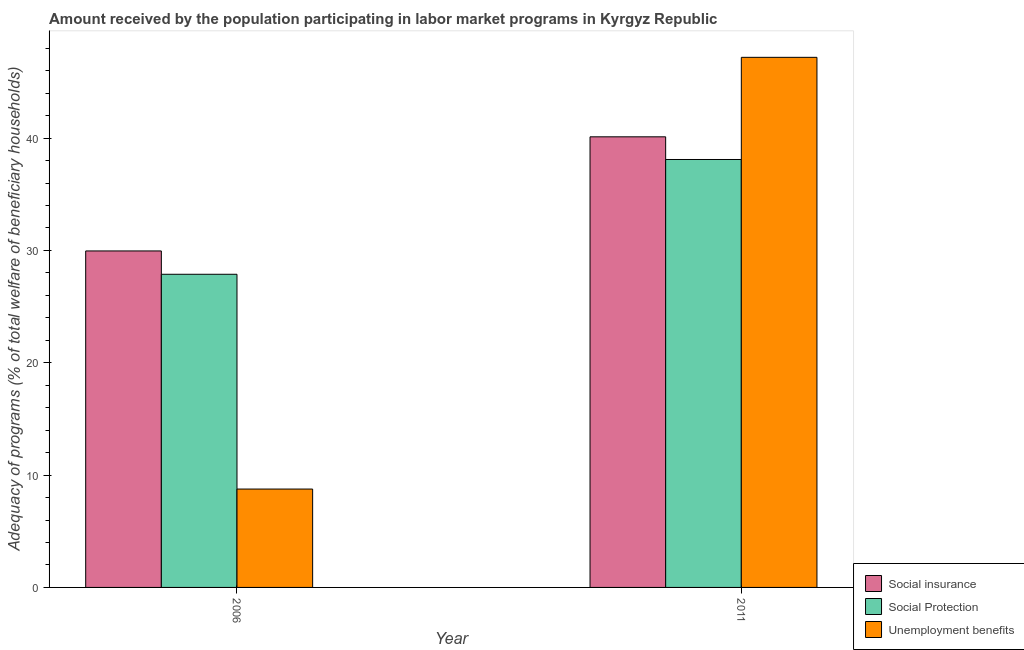Are the number of bars per tick equal to the number of legend labels?
Keep it short and to the point. Yes. Are the number of bars on each tick of the X-axis equal?
Offer a terse response. Yes. How many bars are there on the 1st tick from the left?
Make the answer very short. 3. What is the amount received by the population participating in unemployment benefits programs in 2006?
Make the answer very short. 8.76. Across all years, what is the maximum amount received by the population participating in social protection programs?
Offer a terse response. 38.1. Across all years, what is the minimum amount received by the population participating in unemployment benefits programs?
Make the answer very short. 8.76. In which year was the amount received by the population participating in social protection programs minimum?
Ensure brevity in your answer.  2006. What is the total amount received by the population participating in unemployment benefits programs in the graph?
Offer a terse response. 55.95. What is the difference between the amount received by the population participating in social protection programs in 2006 and that in 2011?
Offer a terse response. -10.22. What is the difference between the amount received by the population participating in social protection programs in 2011 and the amount received by the population participating in social insurance programs in 2006?
Ensure brevity in your answer.  10.22. What is the average amount received by the population participating in social protection programs per year?
Your answer should be compact. 32.99. In the year 2011, what is the difference between the amount received by the population participating in unemployment benefits programs and amount received by the population participating in social insurance programs?
Your answer should be very brief. 0. What is the ratio of the amount received by the population participating in social protection programs in 2006 to that in 2011?
Your response must be concise. 0.73. Is the amount received by the population participating in social protection programs in 2006 less than that in 2011?
Keep it short and to the point. Yes. In how many years, is the amount received by the population participating in social insurance programs greater than the average amount received by the population participating in social insurance programs taken over all years?
Your answer should be compact. 1. What does the 3rd bar from the left in 2006 represents?
Ensure brevity in your answer.  Unemployment benefits. What does the 3rd bar from the right in 2011 represents?
Offer a very short reply. Social insurance. How many bars are there?
Ensure brevity in your answer.  6. How many years are there in the graph?
Provide a short and direct response. 2. What is the difference between two consecutive major ticks on the Y-axis?
Keep it short and to the point. 10. Are the values on the major ticks of Y-axis written in scientific E-notation?
Ensure brevity in your answer.  No. Does the graph contain grids?
Your response must be concise. No. How are the legend labels stacked?
Keep it short and to the point. Vertical. What is the title of the graph?
Ensure brevity in your answer.  Amount received by the population participating in labor market programs in Kyrgyz Republic. What is the label or title of the Y-axis?
Your response must be concise. Adequacy of programs (% of total welfare of beneficiary households). What is the Adequacy of programs (% of total welfare of beneficiary households) of Social insurance in 2006?
Your answer should be compact. 29.96. What is the Adequacy of programs (% of total welfare of beneficiary households) of Social Protection in 2006?
Keep it short and to the point. 27.88. What is the Adequacy of programs (% of total welfare of beneficiary households) of Unemployment benefits in 2006?
Your answer should be very brief. 8.76. What is the Adequacy of programs (% of total welfare of beneficiary households) in Social insurance in 2011?
Provide a succinct answer. 40.12. What is the Adequacy of programs (% of total welfare of beneficiary households) of Social Protection in 2011?
Offer a very short reply. 38.1. What is the Adequacy of programs (% of total welfare of beneficiary households) of Unemployment benefits in 2011?
Keep it short and to the point. 47.19. Across all years, what is the maximum Adequacy of programs (% of total welfare of beneficiary households) of Social insurance?
Your answer should be compact. 40.12. Across all years, what is the maximum Adequacy of programs (% of total welfare of beneficiary households) of Social Protection?
Give a very brief answer. 38.1. Across all years, what is the maximum Adequacy of programs (% of total welfare of beneficiary households) of Unemployment benefits?
Your answer should be very brief. 47.19. Across all years, what is the minimum Adequacy of programs (% of total welfare of beneficiary households) in Social insurance?
Offer a very short reply. 29.96. Across all years, what is the minimum Adequacy of programs (% of total welfare of beneficiary households) in Social Protection?
Ensure brevity in your answer.  27.88. Across all years, what is the minimum Adequacy of programs (% of total welfare of beneficiary households) in Unemployment benefits?
Your answer should be very brief. 8.76. What is the total Adequacy of programs (% of total welfare of beneficiary households) in Social insurance in the graph?
Provide a succinct answer. 70.07. What is the total Adequacy of programs (% of total welfare of beneficiary households) of Social Protection in the graph?
Give a very brief answer. 65.98. What is the total Adequacy of programs (% of total welfare of beneficiary households) in Unemployment benefits in the graph?
Make the answer very short. 55.95. What is the difference between the Adequacy of programs (% of total welfare of beneficiary households) in Social insurance in 2006 and that in 2011?
Your answer should be very brief. -10.16. What is the difference between the Adequacy of programs (% of total welfare of beneficiary households) of Social Protection in 2006 and that in 2011?
Offer a very short reply. -10.22. What is the difference between the Adequacy of programs (% of total welfare of beneficiary households) in Unemployment benefits in 2006 and that in 2011?
Your answer should be compact. -38.43. What is the difference between the Adequacy of programs (% of total welfare of beneficiary households) of Social insurance in 2006 and the Adequacy of programs (% of total welfare of beneficiary households) of Social Protection in 2011?
Your answer should be very brief. -8.14. What is the difference between the Adequacy of programs (% of total welfare of beneficiary households) in Social insurance in 2006 and the Adequacy of programs (% of total welfare of beneficiary households) in Unemployment benefits in 2011?
Your answer should be compact. -17.24. What is the difference between the Adequacy of programs (% of total welfare of beneficiary households) in Social Protection in 2006 and the Adequacy of programs (% of total welfare of beneficiary households) in Unemployment benefits in 2011?
Ensure brevity in your answer.  -19.31. What is the average Adequacy of programs (% of total welfare of beneficiary households) of Social insurance per year?
Your answer should be very brief. 35.04. What is the average Adequacy of programs (% of total welfare of beneficiary households) of Social Protection per year?
Provide a short and direct response. 32.99. What is the average Adequacy of programs (% of total welfare of beneficiary households) of Unemployment benefits per year?
Offer a very short reply. 27.98. In the year 2006, what is the difference between the Adequacy of programs (% of total welfare of beneficiary households) in Social insurance and Adequacy of programs (% of total welfare of beneficiary households) in Social Protection?
Your response must be concise. 2.08. In the year 2006, what is the difference between the Adequacy of programs (% of total welfare of beneficiary households) of Social insurance and Adequacy of programs (% of total welfare of beneficiary households) of Unemployment benefits?
Your response must be concise. 21.2. In the year 2006, what is the difference between the Adequacy of programs (% of total welfare of beneficiary households) of Social Protection and Adequacy of programs (% of total welfare of beneficiary households) of Unemployment benefits?
Keep it short and to the point. 19.12. In the year 2011, what is the difference between the Adequacy of programs (% of total welfare of beneficiary households) in Social insurance and Adequacy of programs (% of total welfare of beneficiary households) in Social Protection?
Make the answer very short. 2.02. In the year 2011, what is the difference between the Adequacy of programs (% of total welfare of beneficiary households) of Social insurance and Adequacy of programs (% of total welfare of beneficiary households) of Unemployment benefits?
Your answer should be very brief. -7.08. In the year 2011, what is the difference between the Adequacy of programs (% of total welfare of beneficiary households) in Social Protection and Adequacy of programs (% of total welfare of beneficiary households) in Unemployment benefits?
Give a very brief answer. -9.09. What is the ratio of the Adequacy of programs (% of total welfare of beneficiary households) of Social insurance in 2006 to that in 2011?
Your answer should be compact. 0.75. What is the ratio of the Adequacy of programs (% of total welfare of beneficiary households) in Social Protection in 2006 to that in 2011?
Your answer should be compact. 0.73. What is the ratio of the Adequacy of programs (% of total welfare of beneficiary households) in Unemployment benefits in 2006 to that in 2011?
Your response must be concise. 0.19. What is the difference between the highest and the second highest Adequacy of programs (% of total welfare of beneficiary households) of Social insurance?
Give a very brief answer. 10.16. What is the difference between the highest and the second highest Adequacy of programs (% of total welfare of beneficiary households) in Social Protection?
Keep it short and to the point. 10.22. What is the difference between the highest and the second highest Adequacy of programs (% of total welfare of beneficiary households) in Unemployment benefits?
Provide a succinct answer. 38.43. What is the difference between the highest and the lowest Adequacy of programs (% of total welfare of beneficiary households) in Social insurance?
Your answer should be very brief. 10.16. What is the difference between the highest and the lowest Adequacy of programs (% of total welfare of beneficiary households) in Social Protection?
Make the answer very short. 10.22. What is the difference between the highest and the lowest Adequacy of programs (% of total welfare of beneficiary households) of Unemployment benefits?
Your answer should be compact. 38.43. 